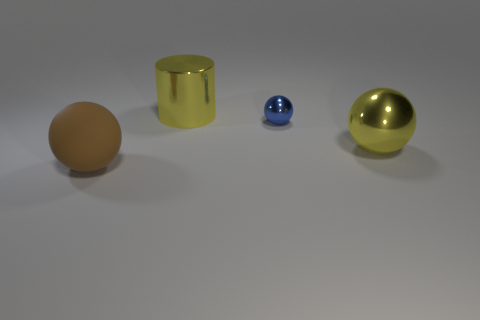Add 1 small balls. How many objects exist? 5 Subtract all spheres. How many objects are left? 1 Subtract all yellow cylinders. Subtract all yellow things. How many objects are left? 1 Add 3 yellow metal spheres. How many yellow metal spheres are left? 4 Add 3 yellow shiny things. How many yellow shiny things exist? 5 Subtract 0 red cubes. How many objects are left? 4 